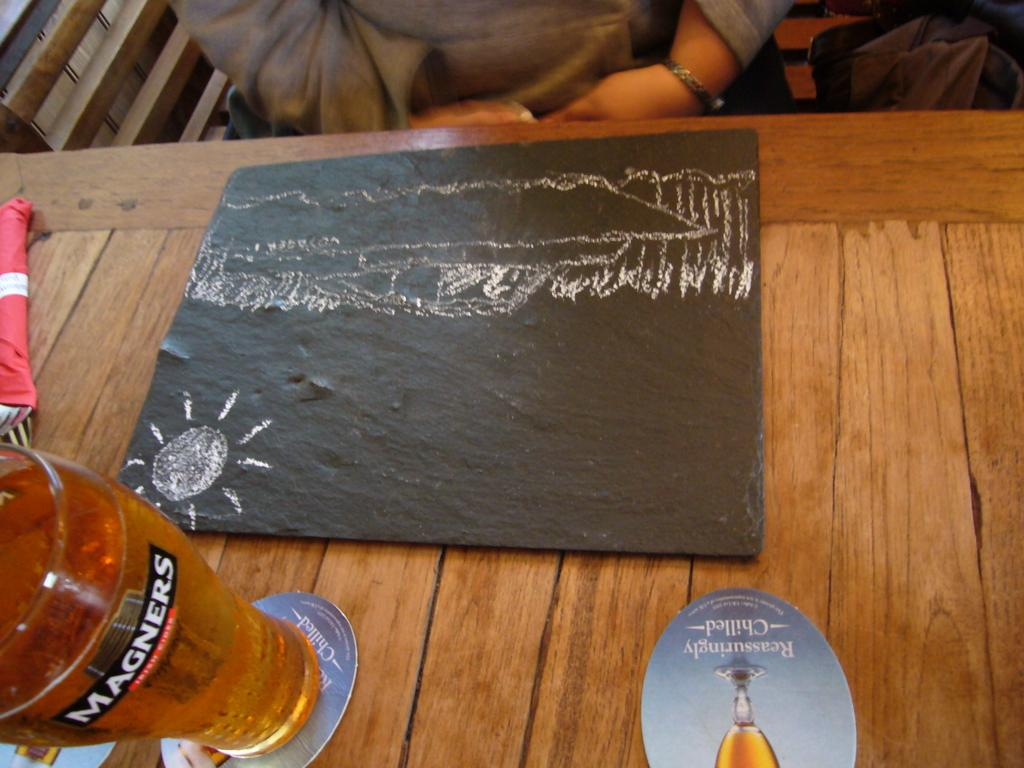<image>
Relay a brief, clear account of the picture shown. A magners glass with beer in it on a brown table near a kids drawing. 